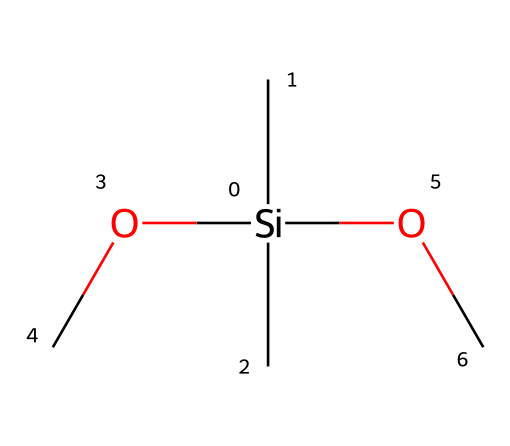How many silicon atoms are present in this chemical structure? The SMILES representation indicates a single silicon atom, represented by [Si]. There are no other silicon atoms mentioned in the molecular structure.
Answer: 1 What type of functional groups are present in this organosilicon compound? The compound features alkoxy groups (-OC) adjacent to the silicon atom, indicating the presence of ether functional groups. These can be identified from the -O- linkages with carbon atoms from the methoxy (-C) parts of the structure.
Answer: ether How many carbon atoms are in the molecule? By analyzing the SMILES representation, the chemical contains four carbon atoms—three from the methyl groups (C) and one from the methoxy group (OC).
Answer: 4 What is the coordination number of the silicon atom? Silicon is tetravalent and forms four bonds: two with methyl groups (C), one with an ether oxygen atom (O), and one with another ether oxygen (OC). This means the coordination number, which counts the number of immediate neighboring atoms, is four.
Answer: 4 What type of chemical is this compound primarily classified as? Given that it contains silicon and carbon in its structure, along with functional groups typical of organosilicon compounds, this molecule is classified as a silicone.
Answer: silicone Which property does the presence of silicon contribute to this lubricant? Silicon-based compounds typically provide high-temperature stability and flexibility, allowing for efficient lubrication under various conditions, especially in sports equipment like baseball bats where performance is key.
Answer: stability 